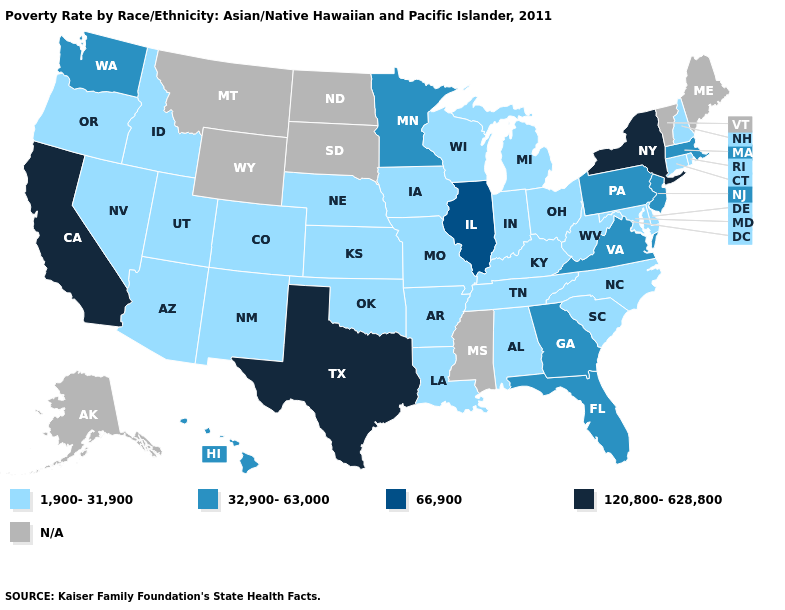Name the states that have a value in the range 1,900-31,900?
Answer briefly. Alabama, Arizona, Arkansas, Colorado, Connecticut, Delaware, Idaho, Indiana, Iowa, Kansas, Kentucky, Louisiana, Maryland, Michigan, Missouri, Nebraska, Nevada, New Hampshire, New Mexico, North Carolina, Ohio, Oklahoma, Oregon, Rhode Island, South Carolina, Tennessee, Utah, West Virginia, Wisconsin. What is the value of Nebraska?
Concise answer only. 1,900-31,900. Name the states that have a value in the range 66,900?
Give a very brief answer. Illinois. Does Illinois have the lowest value in the USA?
Quick response, please. No. What is the value of South Carolina?
Answer briefly. 1,900-31,900. Name the states that have a value in the range 120,800-628,800?
Concise answer only. California, New York, Texas. Among the states that border Pennsylvania , which have the lowest value?
Give a very brief answer. Delaware, Maryland, Ohio, West Virginia. Which states have the lowest value in the USA?
Be succinct. Alabama, Arizona, Arkansas, Colorado, Connecticut, Delaware, Idaho, Indiana, Iowa, Kansas, Kentucky, Louisiana, Maryland, Michigan, Missouri, Nebraska, Nevada, New Hampshire, New Mexico, North Carolina, Ohio, Oklahoma, Oregon, Rhode Island, South Carolina, Tennessee, Utah, West Virginia, Wisconsin. Which states have the lowest value in the MidWest?
Write a very short answer. Indiana, Iowa, Kansas, Michigan, Missouri, Nebraska, Ohio, Wisconsin. Name the states that have a value in the range N/A?
Write a very short answer. Alaska, Maine, Mississippi, Montana, North Dakota, South Dakota, Vermont, Wyoming. What is the value of Massachusetts?
Quick response, please. 32,900-63,000. What is the value of West Virginia?
Concise answer only. 1,900-31,900. Does Pennsylvania have the lowest value in the USA?
Quick response, please. No. Is the legend a continuous bar?
Answer briefly. No. 